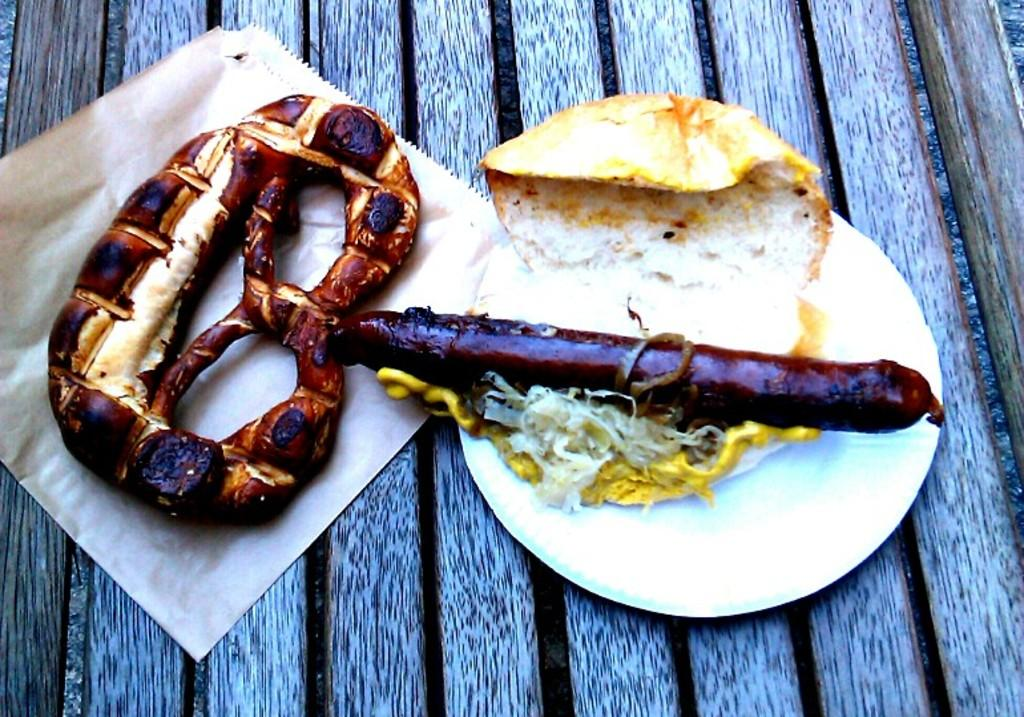What is present on the wooden platform in the image? There is a plate, a paper, and food items placed on the wooden platform in the image. What is the purpose of the paper in the image? The purpose of the paper in the image is not specified, but it could be used for various purposes such as wrapping or serving food. What type of surface is the wooden platform? The wooden platform is a solid surface made of wood. How are the food items arranged on the wooden platform? The arrangement of the food items on the wooden platform is not specified in the facts, so we cannot determine their arrangement. What advice is given on the paper in the image? There is no indication in the image that the paper contains any advice. The purpose of the paper is not specified, so we cannot determine if it contains advice or not. 